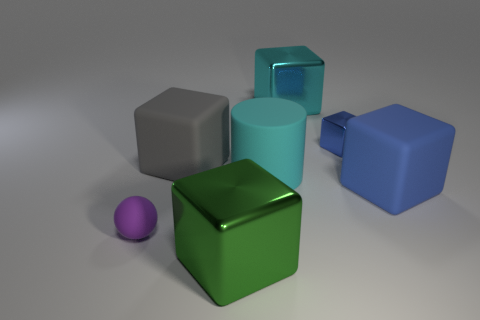Does the purple object have the same size as the shiny block in front of the small purple ball? The purple object does not have the same size as the shiny block; the purple object is smaller in scale compared to the shiny teal block situated closer to the foreground, adjacent to the purple ball. 